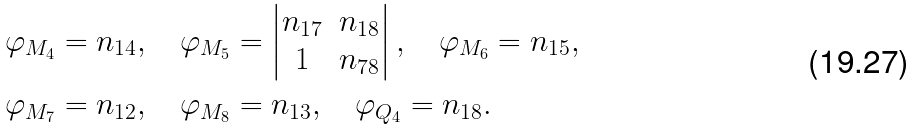<formula> <loc_0><loc_0><loc_500><loc_500>\varphi _ { M _ { 4 } } & = n _ { 1 4 } , \quad \varphi _ { M _ { 5 } } = \left | \begin{matrix} n _ { 1 7 } & n _ { 1 8 } \\ 1 & n _ { 7 8 } \end{matrix} \right | , \quad \varphi _ { M _ { 6 } } = n _ { 1 5 } , \\ \varphi _ { M _ { 7 } } & = n _ { 1 2 } , \quad \varphi _ { M _ { 8 } } = n _ { 1 3 } , \quad \varphi _ { Q _ { 4 } } = n _ { 1 8 } .</formula> 